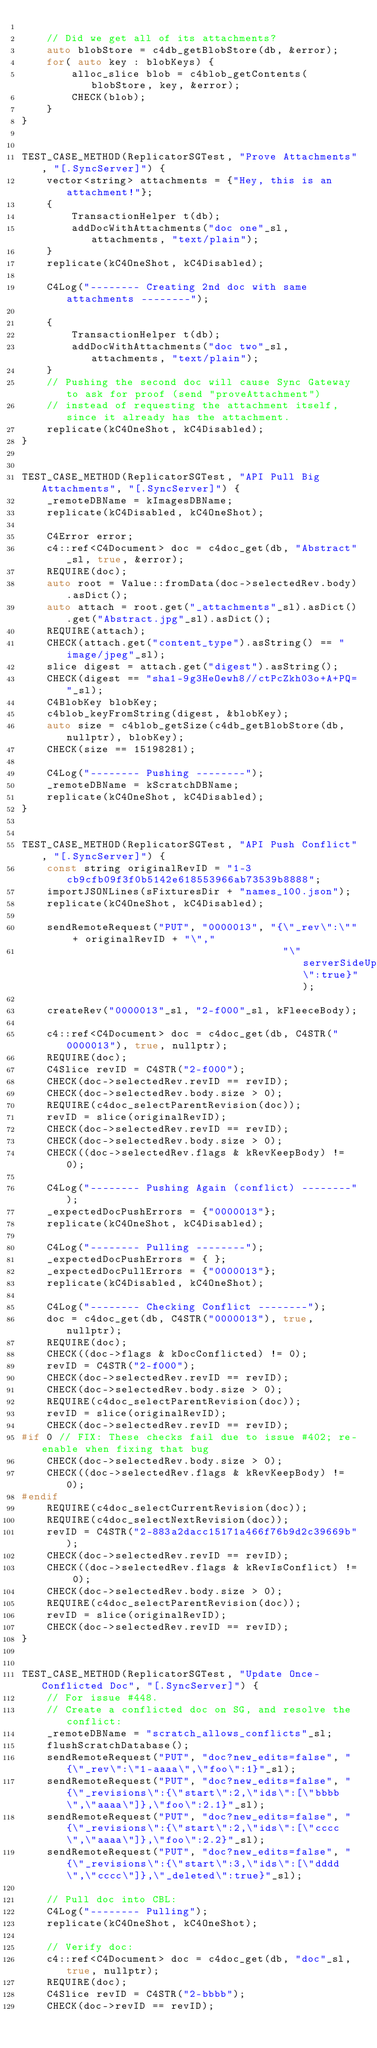Convert code to text. <code><loc_0><loc_0><loc_500><loc_500><_C++_>
    // Did we get all of its attachments?
    auto blobStore = c4db_getBlobStore(db, &error);
    for( auto key : blobKeys) {
        alloc_slice blob = c4blob_getContents(blobStore, key, &error);
        CHECK(blob);
    }
}


TEST_CASE_METHOD(ReplicatorSGTest, "Prove Attachments", "[.SyncServer]") {
    vector<string> attachments = {"Hey, this is an attachment!"};
    {
        TransactionHelper t(db);
        addDocWithAttachments("doc one"_sl, attachments, "text/plain");
    }
    replicate(kC4OneShot, kC4Disabled);

    C4Log("-------- Creating 2nd doc with same attachments --------");

    {
        TransactionHelper t(db);
        addDocWithAttachments("doc two"_sl, attachments, "text/plain");
    }
    // Pushing the second doc will cause Sync Gateway to ask for proof (send "proveAttachment")
    // instead of requesting the attachment itself, since it already has the attachment.
    replicate(kC4OneShot, kC4Disabled);
}


TEST_CASE_METHOD(ReplicatorSGTest, "API Pull Big Attachments", "[.SyncServer]") {
    _remoteDBName = kImagesDBName;
    replicate(kC4Disabled, kC4OneShot);

    C4Error error;
    c4::ref<C4Document> doc = c4doc_get(db, "Abstract"_sl, true, &error);
    REQUIRE(doc);
    auto root = Value::fromData(doc->selectedRev.body).asDict();
    auto attach = root.get("_attachments"_sl).asDict().get("Abstract.jpg"_sl).asDict();
    REQUIRE(attach);
    CHECK(attach.get("content_type").asString() == "image/jpeg"_sl);
    slice digest = attach.get("digest").asString();
    CHECK(digest == "sha1-9g3HeOewh8//ctPcZkh03o+A+PQ="_sl);
    C4BlobKey blobKey;
    c4blob_keyFromString(digest, &blobKey);
    auto size = c4blob_getSize(c4db_getBlobStore(db, nullptr), blobKey);
    CHECK(size == 15198281);

    C4Log("-------- Pushing --------");
    _remoteDBName = kScratchDBName;
    replicate(kC4OneShot, kC4Disabled);
}


TEST_CASE_METHOD(ReplicatorSGTest, "API Push Conflict", "[.SyncServer]") {
    const string originalRevID = "1-3cb9cfb09f3f0b5142e618553966ab73539b8888";
    importJSONLines(sFixturesDir + "names_100.json");
    replicate(kC4OneShot, kC4Disabled);

    sendRemoteRequest("PUT", "0000013", "{\"_rev\":\"" + originalRevID + "\","
                                          "\"serverSideUpdate\":true}");

    createRev("0000013"_sl, "2-f000"_sl, kFleeceBody);

    c4::ref<C4Document> doc = c4doc_get(db, C4STR("0000013"), true, nullptr);
    REQUIRE(doc);
	C4Slice revID = C4STR("2-f000");
    CHECK(doc->selectedRev.revID == revID);
    CHECK(doc->selectedRev.body.size > 0);
    REQUIRE(c4doc_selectParentRevision(doc));
	revID = slice(originalRevID);
    CHECK(doc->selectedRev.revID == revID);
    CHECK(doc->selectedRev.body.size > 0);
    CHECK((doc->selectedRev.flags & kRevKeepBody) != 0);

    C4Log("-------- Pushing Again (conflict) --------");
    _expectedDocPushErrors = {"0000013"};
    replicate(kC4OneShot, kC4Disabled);

    C4Log("-------- Pulling --------");
    _expectedDocPushErrors = { };
    _expectedDocPullErrors = {"0000013"};
    replicate(kC4Disabled, kC4OneShot);

    C4Log("-------- Checking Conflict --------");
    doc = c4doc_get(db, C4STR("0000013"), true, nullptr);
    REQUIRE(doc);
    CHECK((doc->flags & kDocConflicted) != 0);
	revID = C4STR("2-f000");
    CHECK(doc->selectedRev.revID == revID);
    CHECK(doc->selectedRev.body.size > 0);
    REQUIRE(c4doc_selectParentRevision(doc));
	revID = slice(originalRevID);
    CHECK(doc->selectedRev.revID == revID);
#if 0 // FIX: These checks fail due to issue #402; re-enable when fixing that bug
    CHECK(doc->selectedRev.body.size > 0);
    CHECK((doc->selectedRev.flags & kRevKeepBody) != 0);
#endif
    REQUIRE(c4doc_selectCurrentRevision(doc));
    REQUIRE(c4doc_selectNextRevision(doc));
	revID = C4STR("2-883a2dacc15171a466f76b9d2c39669b");
    CHECK(doc->selectedRev.revID == revID);
    CHECK((doc->selectedRev.flags & kRevIsConflict) != 0);
    CHECK(doc->selectedRev.body.size > 0);
    REQUIRE(c4doc_selectParentRevision(doc));
	revID = slice(originalRevID);
    CHECK(doc->selectedRev.revID == revID);
}


TEST_CASE_METHOD(ReplicatorSGTest, "Update Once-Conflicted Doc", "[.SyncServer]") {
    // For issue #448.
    // Create a conflicted doc on SG, and resolve the conflict:
    _remoteDBName = "scratch_allows_conflicts"_sl;
    flushScratchDatabase();
    sendRemoteRequest("PUT", "doc?new_edits=false", "{\"_rev\":\"1-aaaa\",\"foo\":1}"_sl);
    sendRemoteRequest("PUT", "doc?new_edits=false", "{\"_revisions\":{\"start\":2,\"ids\":[\"bbbb\",\"aaaa\"]},\"foo\":2.1}"_sl);
    sendRemoteRequest("PUT", "doc?new_edits=false", "{\"_revisions\":{\"start\":2,\"ids\":[\"cccc\",\"aaaa\"]},\"foo\":2.2}"_sl);
    sendRemoteRequest("PUT", "doc?new_edits=false", "{\"_revisions\":{\"start\":3,\"ids\":[\"dddd\",\"cccc\"]},\"_deleted\":true}"_sl);

    // Pull doc into CBL:
    C4Log("-------- Pulling");
    replicate(kC4OneShot, kC4OneShot);

    // Verify doc:
    c4::ref<C4Document> doc = c4doc_get(db, "doc"_sl, true, nullptr);
    REQUIRE(doc);
	C4Slice revID = C4STR("2-bbbb");
    CHECK(doc->revID == revID);</code> 